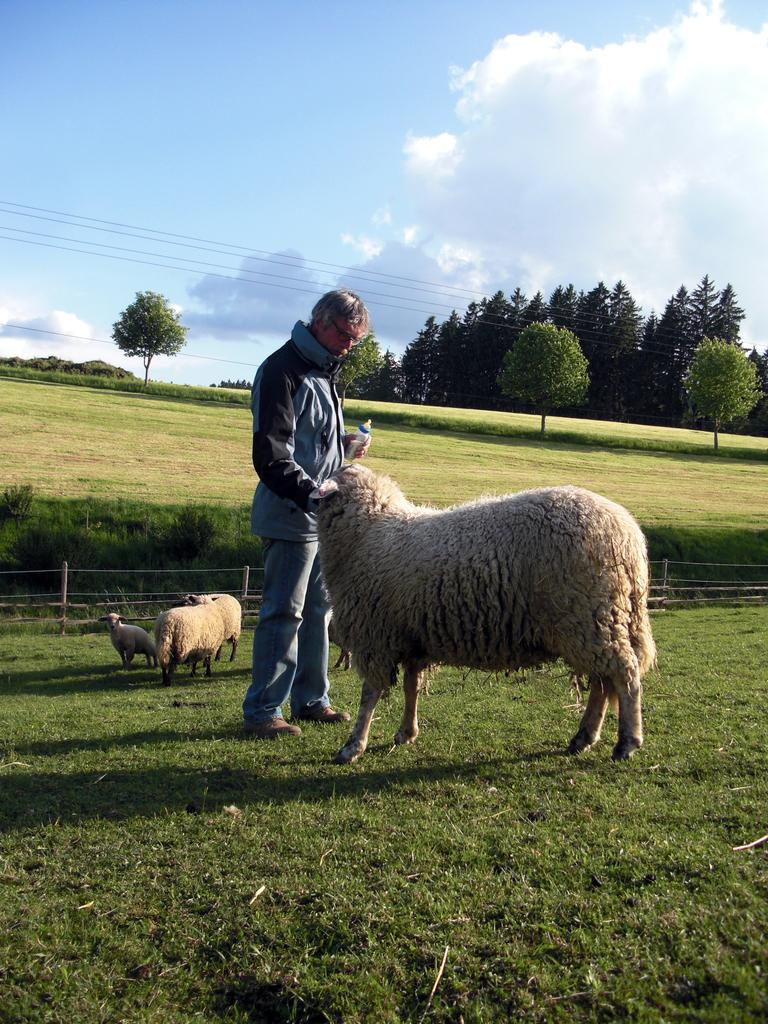What is the man near in the image? There is a man standing near a sheep in the image. What can be seen in the background of the image? In the background, there is a flock of sheep, a wooden fence, bushes, the ground, trees, cables, and the sky with clouds. How many sheep are visible in the image? There is one sheep near the man, and a flock of sheep in the background, so there are at least two sheep visible. What type of enclosure is present in the background? There is a wooden fence in the background. What type of coal can be seen in the image? There is no coal present in the image. What type of copper is visible in the image? There is no copper present in the image. 